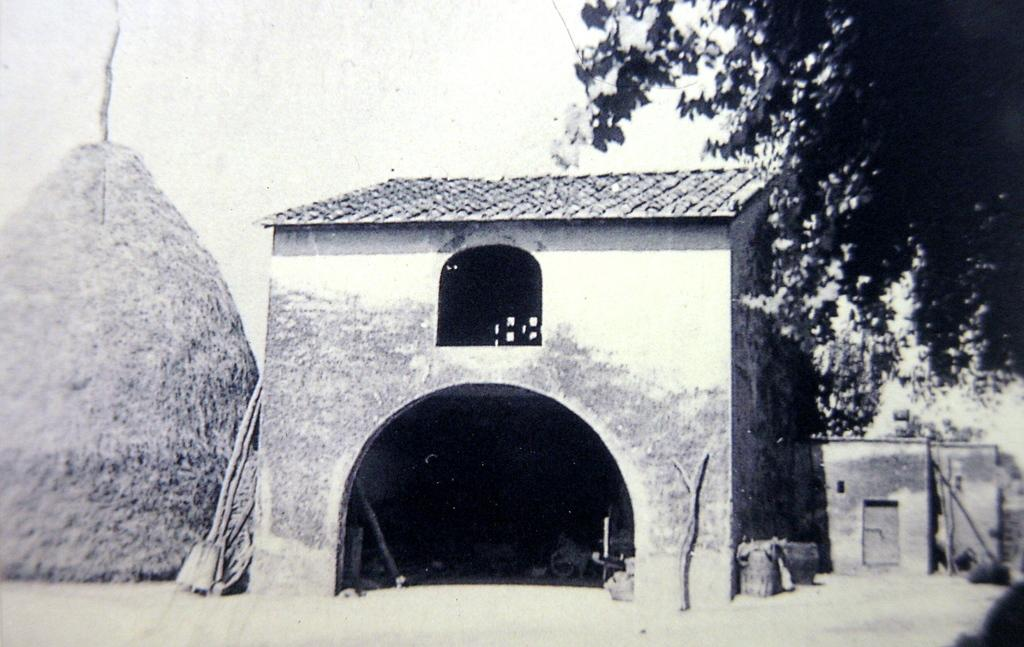What is the color scheme of the image? The image is black and white. What type of structures can be seen in the image? There is a shed and a hut in the image. What type of vegetation is visible in the image? Branches and leaves are present in the image. What can be seen in the background of the image? The sky is visible in the background of the image. What type of flag is being waved by the maid in the image? There is no maid or flag present in the image. What sound can be heard coming from the hut in the image? The image is silent, so no sound can be heard. 